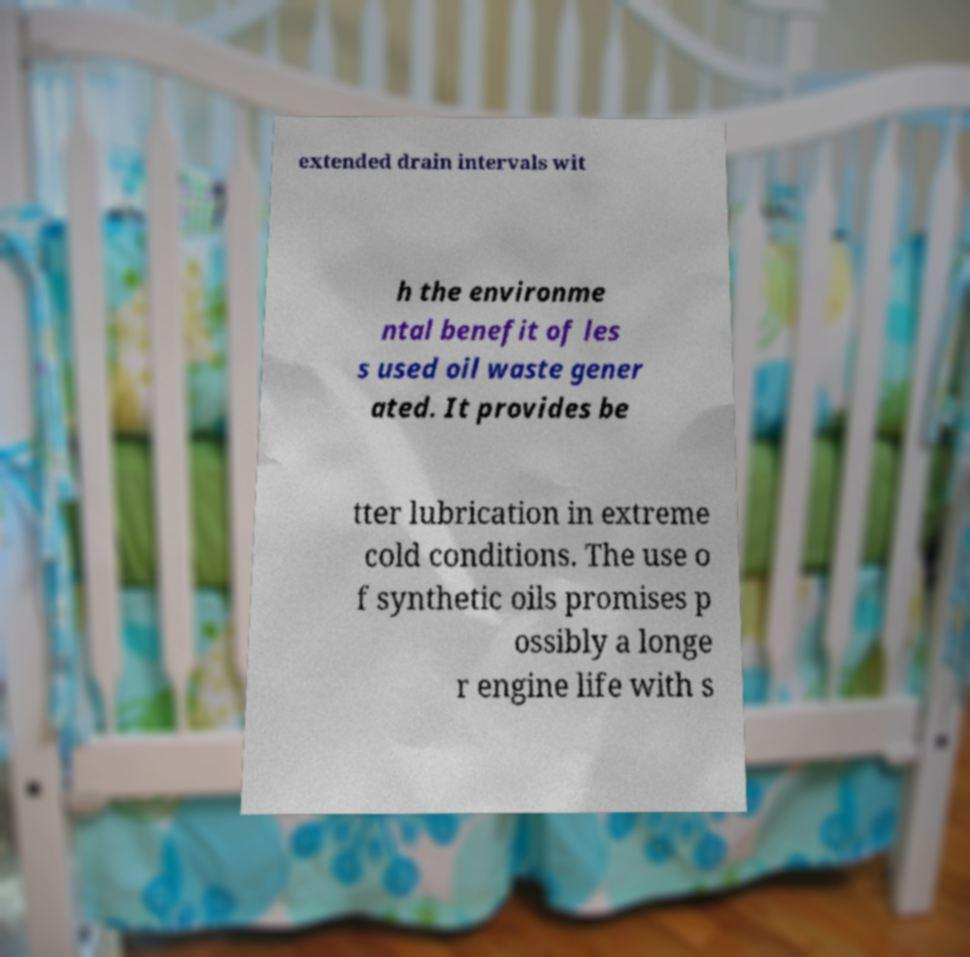For documentation purposes, I need the text within this image transcribed. Could you provide that? extended drain intervals wit h the environme ntal benefit of les s used oil waste gener ated. It provides be tter lubrication in extreme cold conditions. The use o f synthetic oils promises p ossibly a longe r engine life with s 